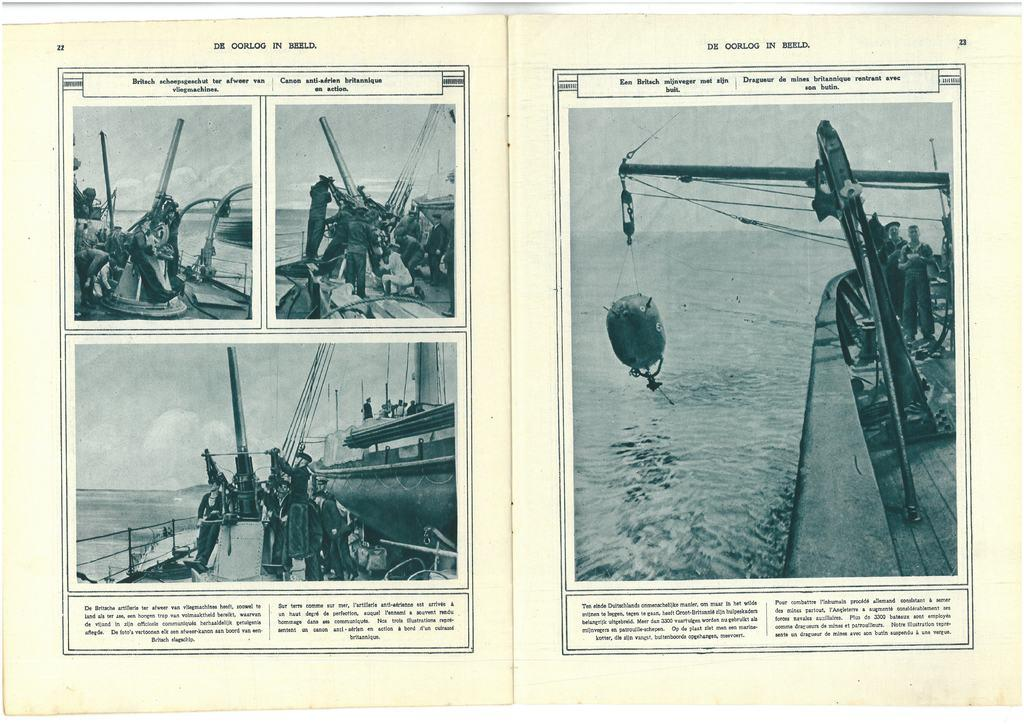What are the people in the image doing? The people in the image are on boats. What can be seen in the background of the image? There is water visible in the background of the image. What is written at the top of the image? There is text written at the top of the image. What is written at the bottom of the image? There is text written at the bottom of the image. Can you see a cow wearing a yoke in the image? There is no cow or yoke present in the image. Are the people on the boats sleeping in the image? There is no indication that the people on the boats are sleeping; they are likely awake and operating the boats. 